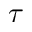<formula> <loc_0><loc_0><loc_500><loc_500>\tau</formula> 